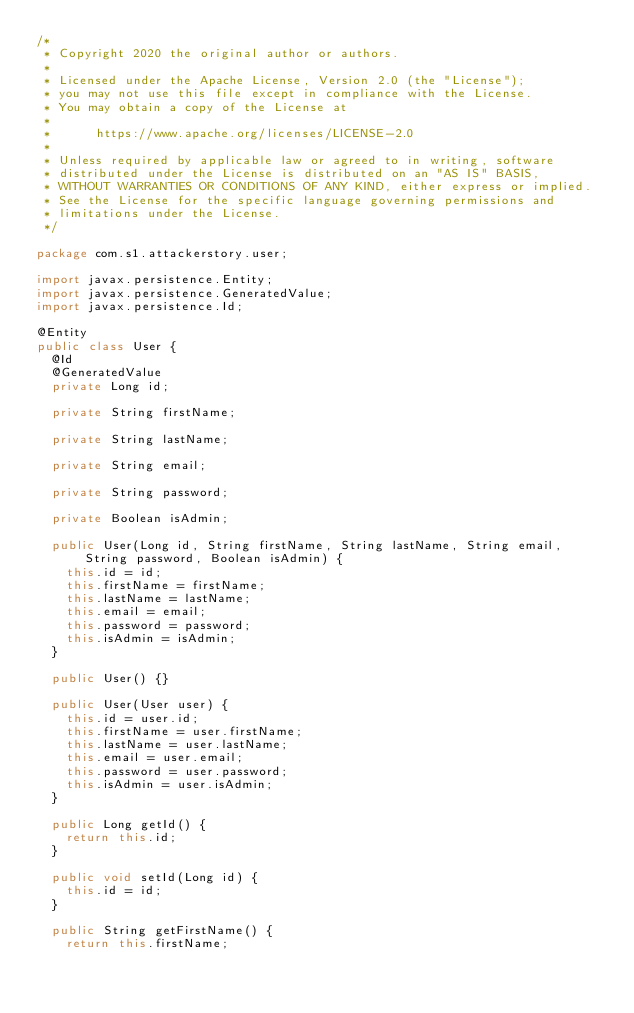Convert code to text. <code><loc_0><loc_0><loc_500><loc_500><_Java_>/*
 * Copyright 2020 the original author or authors.
 *
 * Licensed under the Apache License, Version 2.0 (the "License");
 * you may not use this file except in compliance with the License.
 * You may obtain a copy of the License at
 *
 *      https://www.apache.org/licenses/LICENSE-2.0
 *
 * Unless required by applicable law or agreed to in writing, software
 * distributed under the License is distributed on an "AS IS" BASIS,
 * WITHOUT WARRANTIES OR CONDITIONS OF ANY KIND, either express or implied.
 * See the License for the specific language governing permissions and
 * limitations under the License.
 */

package com.s1.attackerstory.user;

import javax.persistence.Entity;
import javax.persistence.GeneratedValue;
import javax.persistence.Id;

@Entity
public class User {
	@Id
	@GeneratedValue
	private Long id;

	private String firstName;

	private String lastName;

	private String email;

	private String password;

	private Boolean isAdmin;

	public User(Long id, String firstName, String lastName, String email, String password, Boolean isAdmin) {
		this.id = id;
		this.firstName = firstName;
		this.lastName = lastName;
		this.email = email;
		this.password = password;
		this.isAdmin = isAdmin;
	}

	public User() {}

	public User(User user) {
		this.id = user.id;
		this.firstName = user.firstName;
		this.lastName = user.lastName;
		this.email = user.email;
		this.password = user.password;
		this.isAdmin = user.isAdmin;
	}

	public Long getId() {
		return this.id;
	}

	public void setId(Long id) {
		this.id = id;
	}

	public String getFirstName() {
		return this.firstName;</code> 